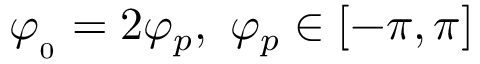Convert formula to latex. <formula><loc_0><loc_0><loc_500><loc_500>\varphi _ { _ { 0 } } = 2 \varphi _ { p } , \ \varphi _ { p } \in [ - \pi , \pi ]</formula> 